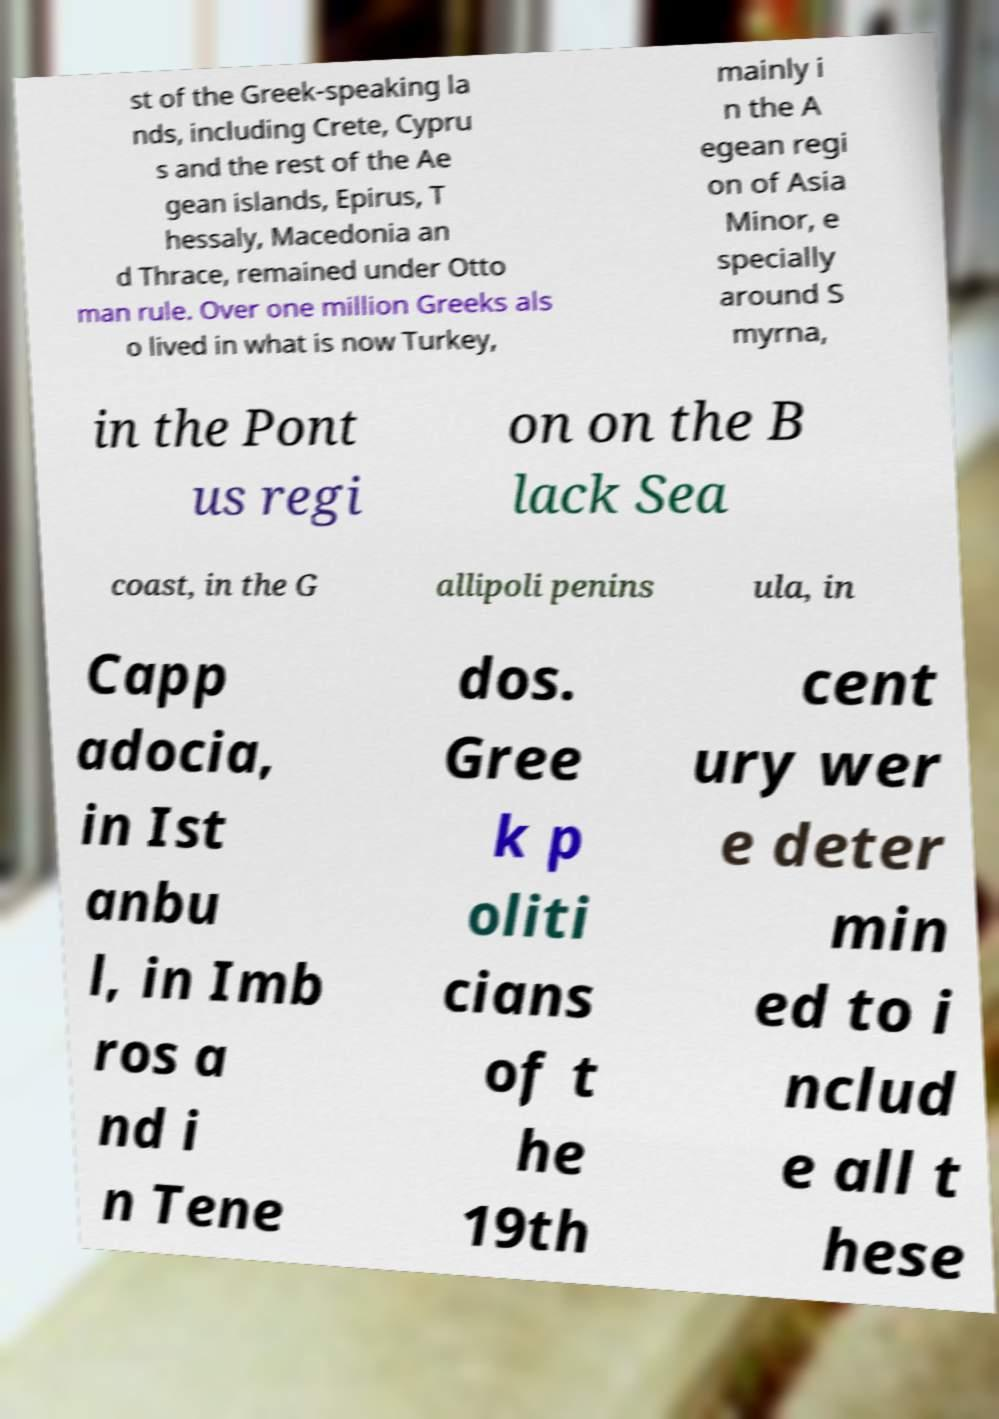I need the written content from this picture converted into text. Can you do that? st of the Greek-speaking la nds, including Crete, Cypru s and the rest of the Ae gean islands, Epirus, T hessaly, Macedonia an d Thrace, remained under Otto man rule. Over one million Greeks als o lived in what is now Turkey, mainly i n the A egean regi on of Asia Minor, e specially around S myrna, in the Pont us regi on on the B lack Sea coast, in the G allipoli penins ula, in Capp adocia, in Ist anbu l, in Imb ros a nd i n Tene dos. Gree k p oliti cians of t he 19th cent ury wer e deter min ed to i nclud e all t hese 